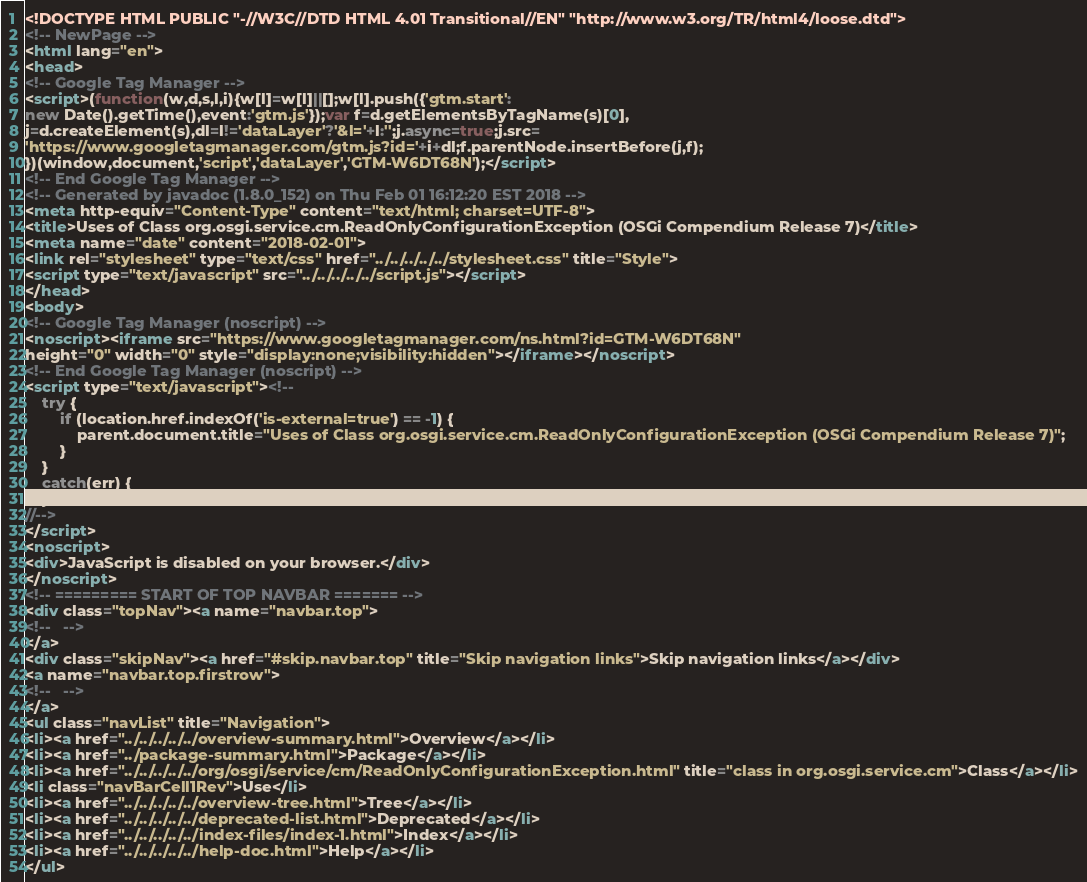<code> <loc_0><loc_0><loc_500><loc_500><_HTML_><!DOCTYPE HTML PUBLIC "-//W3C//DTD HTML 4.01 Transitional//EN" "http://www.w3.org/TR/html4/loose.dtd">
<!-- NewPage -->
<html lang="en">
<head>
<!-- Google Tag Manager -->
<script>(function(w,d,s,l,i){w[l]=w[l]||[];w[l].push({'gtm.start':
new Date().getTime(),event:'gtm.js'});var f=d.getElementsByTagName(s)[0],
j=d.createElement(s),dl=l!='dataLayer'?'&l='+l:'';j.async=true;j.src=
'https://www.googletagmanager.com/gtm.js?id='+i+dl;f.parentNode.insertBefore(j,f);
})(window,document,'script','dataLayer','GTM-W6DT68N');</script>
<!-- End Google Tag Manager -->
<!-- Generated by javadoc (1.8.0_152) on Thu Feb 01 16:12:20 EST 2018 -->
<meta http-equiv="Content-Type" content="text/html; charset=UTF-8">
<title>Uses of Class org.osgi.service.cm.ReadOnlyConfigurationException (OSGi Compendium Release 7)</title>
<meta name="date" content="2018-02-01">
<link rel="stylesheet" type="text/css" href="../../../../../stylesheet.css" title="Style">
<script type="text/javascript" src="../../../../../script.js"></script>
</head>
<body>
<!-- Google Tag Manager (noscript) -->
<noscript><iframe src="https://www.googletagmanager.com/ns.html?id=GTM-W6DT68N"
height="0" width="0" style="display:none;visibility:hidden"></iframe></noscript>
<!-- End Google Tag Manager (noscript) -->
<script type="text/javascript"><!--
    try {
        if (location.href.indexOf('is-external=true') == -1) {
            parent.document.title="Uses of Class org.osgi.service.cm.ReadOnlyConfigurationException (OSGi Compendium Release 7)";
        }
    }
    catch(err) {
    }
//-->
</script>
<noscript>
<div>JavaScript is disabled on your browser.</div>
</noscript>
<!-- ========= START OF TOP NAVBAR ======= -->
<div class="topNav"><a name="navbar.top">
<!--   -->
</a>
<div class="skipNav"><a href="#skip.navbar.top" title="Skip navigation links">Skip navigation links</a></div>
<a name="navbar.top.firstrow">
<!--   -->
</a>
<ul class="navList" title="Navigation">
<li><a href="../../../../../overview-summary.html">Overview</a></li>
<li><a href="../package-summary.html">Package</a></li>
<li><a href="../../../../../org/osgi/service/cm/ReadOnlyConfigurationException.html" title="class in org.osgi.service.cm">Class</a></li>
<li class="navBarCell1Rev">Use</li>
<li><a href="../../../../../overview-tree.html">Tree</a></li>
<li><a href="../../../../../deprecated-list.html">Deprecated</a></li>
<li><a href="../../../../../index-files/index-1.html">Index</a></li>
<li><a href="../../../../../help-doc.html">Help</a></li>
</ul></code> 